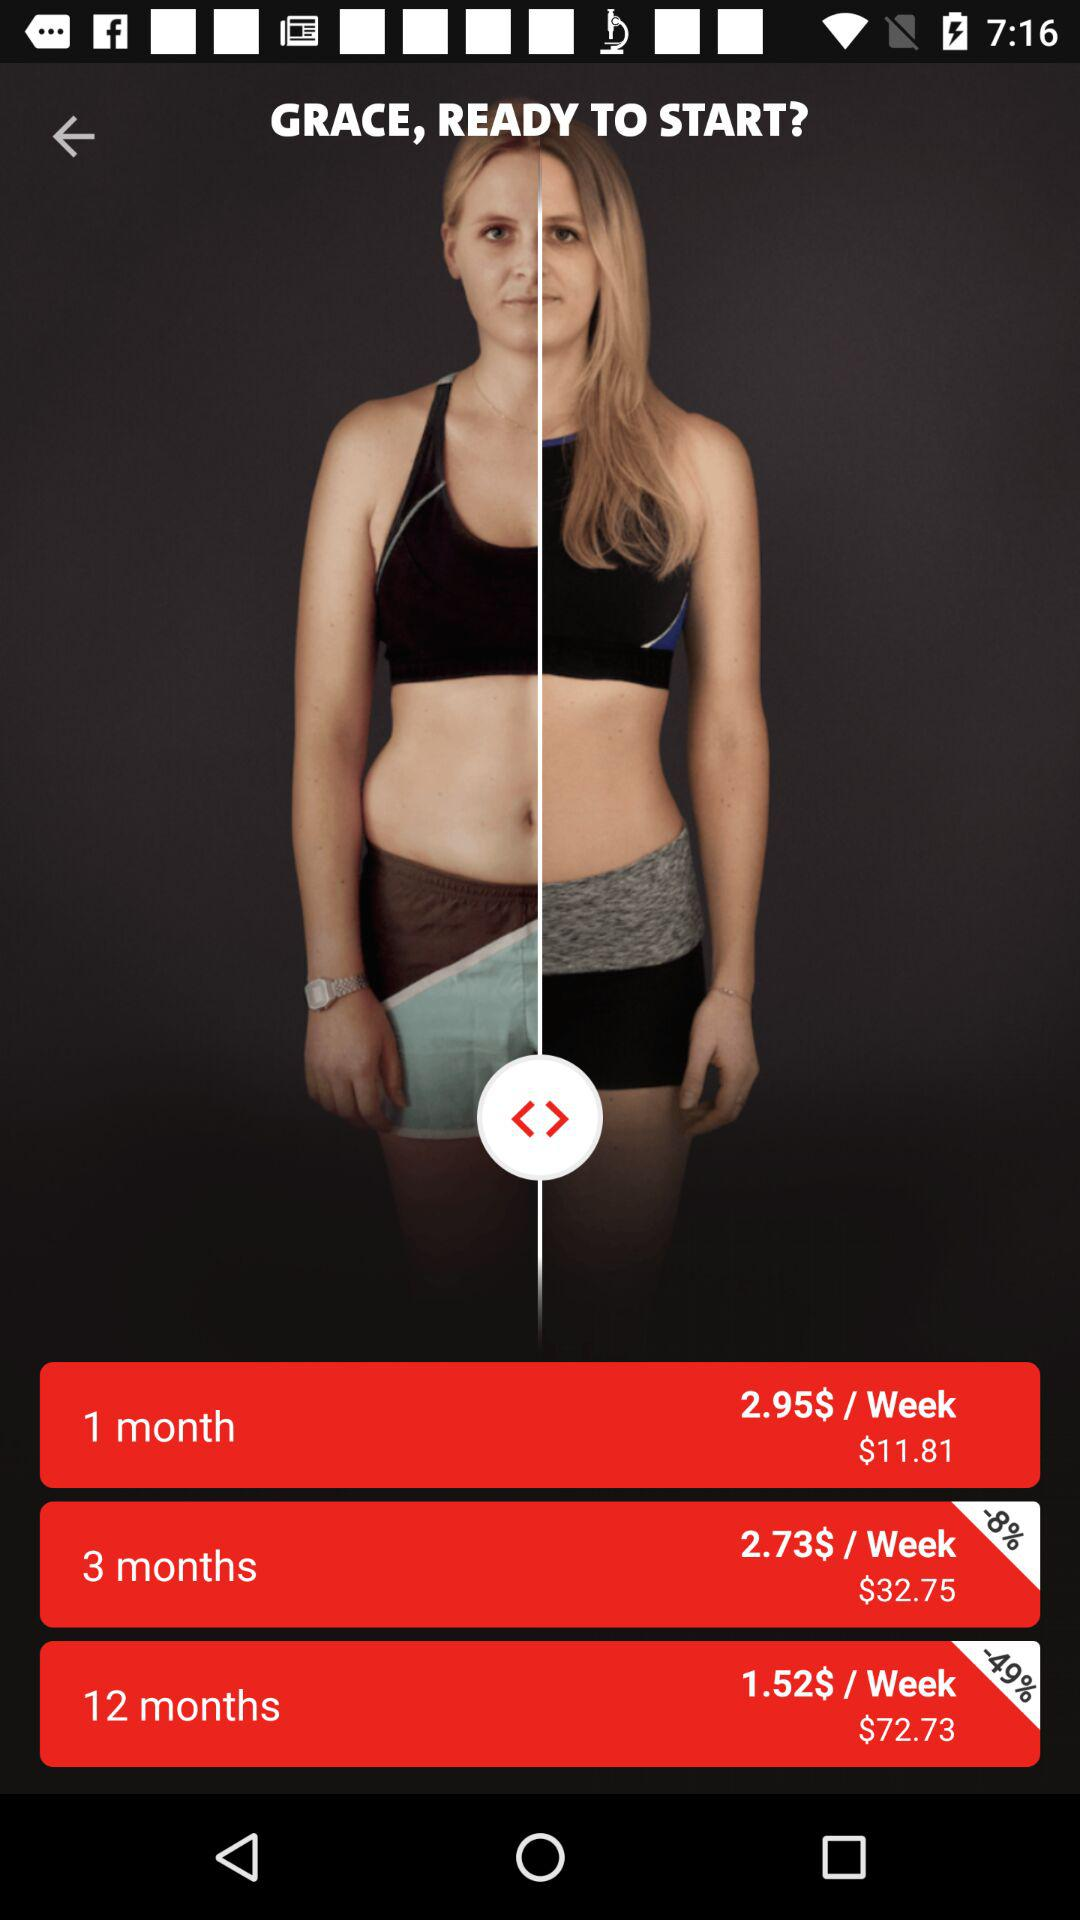How many more dollars does the 12 month plan cost than the 3 month plan?
Answer the question using a single word or phrase. 40 